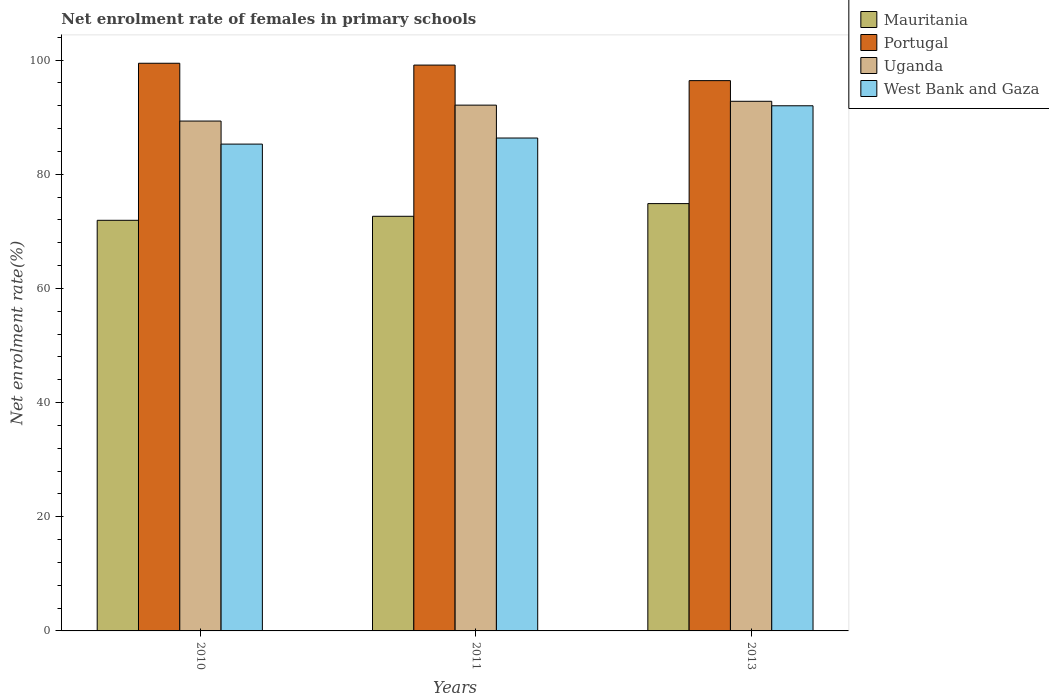How many different coloured bars are there?
Offer a terse response. 4. Are the number of bars per tick equal to the number of legend labels?
Ensure brevity in your answer.  Yes. What is the net enrolment rate of females in primary schools in Uganda in 2011?
Offer a very short reply. 92.12. Across all years, what is the maximum net enrolment rate of females in primary schools in Mauritania?
Offer a very short reply. 74.87. Across all years, what is the minimum net enrolment rate of females in primary schools in Portugal?
Provide a succinct answer. 96.41. In which year was the net enrolment rate of females in primary schools in Uganda maximum?
Provide a succinct answer. 2013. What is the total net enrolment rate of females in primary schools in Uganda in the graph?
Your answer should be compact. 274.25. What is the difference between the net enrolment rate of females in primary schools in Uganda in 2011 and that in 2013?
Offer a very short reply. -0.68. What is the difference between the net enrolment rate of females in primary schools in Mauritania in 2011 and the net enrolment rate of females in primary schools in Uganda in 2010?
Keep it short and to the point. -16.69. What is the average net enrolment rate of females in primary schools in Mauritania per year?
Give a very brief answer. 73.15. In the year 2013, what is the difference between the net enrolment rate of females in primary schools in West Bank and Gaza and net enrolment rate of females in primary schools in Mauritania?
Offer a very short reply. 17.14. What is the ratio of the net enrolment rate of females in primary schools in Mauritania in 2011 to that in 2013?
Your answer should be compact. 0.97. What is the difference between the highest and the second highest net enrolment rate of females in primary schools in Portugal?
Your response must be concise. 0.32. What is the difference between the highest and the lowest net enrolment rate of females in primary schools in West Bank and Gaza?
Ensure brevity in your answer.  6.72. In how many years, is the net enrolment rate of females in primary schools in West Bank and Gaza greater than the average net enrolment rate of females in primary schools in West Bank and Gaza taken over all years?
Your response must be concise. 1. Is the sum of the net enrolment rate of females in primary schools in West Bank and Gaza in 2011 and 2013 greater than the maximum net enrolment rate of females in primary schools in Portugal across all years?
Make the answer very short. Yes. What does the 3rd bar from the left in 2010 represents?
Your answer should be compact. Uganda. What does the 1st bar from the right in 2010 represents?
Your answer should be compact. West Bank and Gaza. Is it the case that in every year, the sum of the net enrolment rate of females in primary schools in West Bank and Gaza and net enrolment rate of females in primary schools in Portugal is greater than the net enrolment rate of females in primary schools in Uganda?
Your answer should be compact. Yes. How many years are there in the graph?
Keep it short and to the point. 3. What is the title of the graph?
Keep it short and to the point. Net enrolment rate of females in primary schools. What is the label or title of the X-axis?
Your response must be concise. Years. What is the label or title of the Y-axis?
Offer a terse response. Net enrolment rate(%). What is the Net enrolment rate(%) in Mauritania in 2010?
Keep it short and to the point. 71.94. What is the Net enrolment rate(%) of Portugal in 2010?
Keep it short and to the point. 99.46. What is the Net enrolment rate(%) of Uganda in 2010?
Your answer should be compact. 89.33. What is the Net enrolment rate(%) in West Bank and Gaza in 2010?
Provide a succinct answer. 85.29. What is the Net enrolment rate(%) of Mauritania in 2011?
Ensure brevity in your answer.  72.65. What is the Net enrolment rate(%) of Portugal in 2011?
Keep it short and to the point. 99.14. What is the Net enrolment rate(%) of Uganda in 2011?
Provide a short and direct response. 92.12. What is the Net enrolment rate(%) in West Bank and Gaza in 2011?
Ensure brevity in your answer.  86.36. What is the Net enrolment rate(%) of Mauritania in 2013?
Your answer should be very brief. 74.87. What is the Net enrolment rate(%) of Portugal in 2013?
Provide a succinct answer. 96.41. What is the Net enrolment rate(%) of Uganda in 2013?
Keep it short and to the point. 92.79. What is the Net enrolment rate(%) of West Bank and Gaza in 2013?
Provide a short and direct response. 92.01. Across all years, what is the maximum Net enrolment rate(%) in Mauritania?
Provide a succinct answer. 74.87. Across all years, what is the maximum Net enrolment rate(%) in Portugal?
Your answer should be compact. 99.46. Across all years, what is the maximum Net enrolment rate(%) of Uganda?
Your answer should be very brief. 92.79. Across all years, what is the maximum Net enrolment rate(%) of West Bank and Gaza?
Offer a very short reply. 92.01. Across all years, what is the minimum Net enrolment rate(%) of Mauritania?
Your answer should be compact. 71.94. Across all years, what is the minimum Net enrolment rate(%) of Portugal?
Provide a succinct answer. 96.41. Across all years, what is the minimum Net enrolment rate(%) in Uganda?
Offer a terse response. 89.33. Across all years, what is the minimum Net enrolment rate(%) in West Bank and Gaza?
Your answer should be compact. 85.29. What is the total Net enrolment rate(%) of Mauritania in the graph?
Offer a terse response. 219.46. What is the total Net enrolment rate(%) in Portugal in the graph?
Your response must be concise. 295.01. What is the total Net enrolment rate(%) of Uganda in the graph?
Keep it short and to the point. 274.25. What is the total Net enrolment rate(%) of West Bank and Gaza in the graph?
Provide a succinct answer. 263.66. What is the difference between the Net enrolment rate(%) of Mauritania in 2010 and that in 2011?
Your response must be concise. -0.7. What is the difference between the Net enrolment rate(%) in Portugal in 2010 and that in 2011?
Offer a very short reply. 0.32. What is the difference between the Net enrolment rate(%) in Uganda in 2010 and that in 2011?
Ensure brevity in your answer.  -2.79. What is the difference between the Net enrolment rate(%) of West Bank and Gaza in 2010 and that in 2011?
Offer a very short reply. -1.06. What is the difference between the Net enrolment rate(%) of Mauritania in 2010 and that in 2013?
Provide a short and direct response. -2.93. What is the difference between the Net enrolment rate(%) of Portugal in 2010 and that in 2013?
Give a very brief answer. 3.04. What is the difference between the Net enrolment rate(%) of Uganda in 2010 and that in 2013?
Offer a very short reply. -3.46. What is the difference between the Net enrolment rate(%) of West Bank and Gaza in 2010 and that in 2013?
Provide a succinct answer. -6.72. What is the difference between the Net enrolment rate(%) of Mauritania in 2011 and that in 2013?
Provide a succinct answer. -2.22. What is the difference between the Net enrolment rate(%) in Portugal in 2011 and that in 2013?
Provide a short and direct response. 2.72. What is the difference between the Net enrolment rate(%) of Uganda in 2011 and that in 2013?
Offer a terse response. -0.68. What is the difference between the Net enrolment rate(%) of West Bank and Gaza in 2011 and that in 2013?
Provide a succinct answer. -5.65. What is the difference between the Net enrolment rate(%) of Mauritania in 2010 and the Net enrolment rate(%) of Portugal in 2011?
Your answer should be compact. -27.19. What is the difference between the Net enrolment rate(%) in Mauritania in 2010 and the Net enrolment rate(%) in Uganda in 2011?
Make the answer very short. -20.18. What is the difference between the Net enrolment rate(%) of Mauritania in 2010 and the Net enrolment rate(%) of West Bank and Gaza in 2011?
Your answer should be compact. -14.42. What is the difference between the Net enrolment rate(%) of Portugal in 2010 and the Net enrolment rate(%) of Uganda in 2011?
Provide a succinct answer. 7.34. What is the difference between the Net enrolment rate(%) in Portugal in 2010 and the Net enrolment rate(%) in West Bank and Gaza in 2011?
Keep it short and to the point. 13.1. What is the difference between the Net enrolment rate(%) of Uganda in 2010 and the Net enrolment rate(%) of West Bank and Gaza in 2011?
Give a very brief answer. 2.97. What is the difference between the Net enrolment rate(%) of Mauritania in 2010 and the Net enrolment rate(%) of Portugal in 2013?
Keep it short and to the point. -24.47. What is the difference between the Net enrolment rate(%) in Mauritania in 2010 and the Net enrolment rate(%) in Uganda in 2013?
Provide a succinct answer. -20.85. What is the difference between the Net enrolment rate(%) in Mauritania in 2010 and the Net enrolment rate(%) in West Bank and Gaza in 2013?
Make the answer very short. -20.07. What is the difference between the Net enrolment rate(%) in Portugal in 2010 and the Net enrolment rate(%) in Uganda in 2013?
Provide a succinct answer. 6.66. What is the difference between the Net enrolment rate(%) in Portugal in 2010 and the Net enrolment rate(%) in West Bank and Gaza in 2013?
Make the answer very short. 7.45. What is the difference between the Net enrolment rate(%) in Uganda in 2010 and the Net enrolment rate(%) in West Bank and Gaza in 2013?
Your response must be concise. -2.68. What is the difference between the Net enrolment rate(%) of Mauritania in 2011 and the Net enrolment rate(%) of Portugal in 2013?
Ensure brevity in your answer.  -23.77. What is the difference between the Net enrolment rate(%) in Mauritania in 2011 and the Net enrolment rate(%) in Uganda in 2013?
Provide a short and direct response. -20.15. What is the difference between the Net enrolment rate(%) in Mauritania in 2011 and the Net enrolment rate(%) in West Bank and Gaza in 2013?
Provide a succinct answer. -19.36. What is the difference between the Net enrolment rate(%) of Portugal in 2011 and the Net enrolment rate(%) of Uganda in 2013?
Offer a very short reply. 6.34. What is the difference between the Net enrolment rate(%) of Portugal in 2011 and the Net enrolment rate(%) of West Bank and Gaza in 2013?
Offer a terse response. 7.13. What is the difference between the Net enrolment rate(%) of Uganda in 2011 and the Net enrolment rate(%) of West Bank and Gaza in 2013?
Offer a terse response. 0.11. What is the average Net enrolment rate(%) of Mauritania per year?
Make the answer very short. 73.15. What is the average Net enrolment rate(%) in Portugal per year?
Provide a short and direct response. 98.34. What is the average Net enrolment rate(%) of Uganda per year?
Your answer should be compact. 91.42. What is the average Net enrolment rate(%) of West Bank and Gaza per year?
Your response must be concise. 87.89. In the year 2010, what is the difference between the Net enrolment rate(%) in Mauritania and Net enrolment rate(%) in Portugal?
Your answer should be very brief. -27.51. In the year 2010, what is the difference between the Net enrolment rate(%) of Mauritania and Net enrolment rate(%) of Uganda?
Your response must be concise. -17.39. In the year 2010, what is the difference between the Net enrolment rate(%) of Mauritania and Net enrolment rate(%) of West Bank and Gaza?
Your answer should be very brief. -13.35. In the year 2010, what is the difference between the Net enrolment rate(%) in Portugal and Net enrolment rate(%) in Uganda?
Offer a very short reply. 10.13. In the year 2010, what is the difference between the Net enrolment rate(%) in Portugal and Net enrolment rate(%) in West Bank and Gaza?
Offer a terse response. 14.16. In the year 2010, what is the difference between the Net enrolment rate(%) of Uganda and Net enrolment rate(%) of West Bank and Gaza?
Your answer should be very brief. 4.04. In the year 2011, what is the difference between the Net enrolment rate(%) of Mauritania and Net enrolment rate(%) of Portugal?
Provide a succinct answer. -26.49. In the year 2011, what is the difference between the Net enrolment rate(%) in Mauritania and Net enrolment rate(%) in Uganda?
Your answer should be compact. -19.47. In the year 2011, what is the difference between the Net enrolment rate(%) of Mauritania and Net enrolment rate(%) of West Bank and Gaza?
Your answer should be very brief. -13.71. In the year 2011, what is the difference between the Net enrolment rate(%) in Portugal and Net enrolment rate(%) in Uganda?
Provide a succinct answer. 7.02. In the year 2011, what is the difference between the Net enrolment rate(%) in Portugal and Net enrolment rate(%) in West Bank and Gaza?
Give a very brief answer. 12.78. In the year 2011, what is the difference between the Net enrolment rate(%) in Uganda and Net enrolment rate(%) in West Bank and Gaza?
Provide a succinct answer. 5.76. In the year 2013, what is the difference between the Net enrolment rate(%) of Mauritania and Net enrolment rate(%) of Portugal?
Keep it short and to the point. -21.55. In the year 2013, what is the difference between the Net enrolment rate(%) of Mauritania and Net enrolment rate(%) of Uganda?
Give a very brief answer. -17.93. In the year 2013, what is the difference between the Net enrolment rate(%) of Mauritania and Net enrolment rate(%) of West Bank and Gaza?
Provide a short and direct response. -17.14. In the year 2013, what is the difference between the Net enrolment rate(%) of Portugal and Net enrolment rate(%) of Uganda?
Offer a very short reply. 3.62. In the year 2013, what is the difference between the Net enrolment rate(%) in Portugal and Net enrolment rate(%) in West Bank and Gaza?
Provide a succinct answer. 4.41. In the year 2013, what is the difference between the Net enrolment rate(%) in Uganda and Net enrolment rate(%) in West Bank and Gaza?
Keep it short and to the point. 0.79. What is the ratio of the Net enrolment rate(%) in Mauritania in 2010 to that in 2011?
Provide a succinct answer. 0.99. What is the ratio of the Net enrolment rate(%) in Uganda in 2010 to that in 2011?
Make the answer very short. 0.97. What is the ratio of the Net enrolment rate(%) of Mauritania in 2010 to that in 2013?
Provide a short and direct response. 0.96. What is the ratio of the Net enrolment rate(%) in Portugal in 2010 to that in 2013?
Provide a succinct answer. 1.03. What is the ratio of the Net enrolment rate(%) of Uganda in 2010 to that in 2013?
Ensure brevity in your answer.  0.96. What is the ratio of the Net enrolment rate(%) of West Bank and Gaza in 2010 to that in 2013?
Give a very brief answer. 0.93. What is the ratio of the Net enrolment rate(%) of Mauritania in 2011 to that in 2013?
Make the answer very short. 0.97. What is the ratio of the Net enrolment rate(%) of Portugal in 2011 to that in 2013?
Make the answer very short. 1.03. What is the ratio of the Net enrolment rate(%) in Uganda in 2011 to that in 2013?
Provide a short and direct response. 0.99. What is the ratio of the Net enrolment rate(%) in West Bank and Gaza in 2011 to that in 2013?
Offer a terse response. 0.94. What is the difference between the highest and the second highest Net enrolment rate(%) of Mauritania?
Give a very brief answer. 2.22. What is the difference between the highest and the second highest Net enrolment rate(%) of Portugal?
Provide a short and direct response. 0.32. What is the difference between the highest and the second highest Net enrolment rate(%) of Uganda?
Your answer should be compact. 0.68. What is the difference between the highest and the second highest Net enrolment rate(%) of West Bank and Gaza?
Offer a very short reply. 5.65. What is the difference between the highest and the lowest Net enrolment rate(%) in Mauritania?
Provide a short and direct response. 2.93. What is the difference between the highest and the lowest Net enrolment rate(%) of Portugal?
Your response must be concise. 3.04. What is the difference between the highest and the lowest Net enrolment rate(%) of Uganda?
Give a very brief answer. 3.46. What is the difference between the highest and the lowest Net enrolment rate(%) in West Bank and Gaza?
Ensure brevity in your answer.  6.72. 